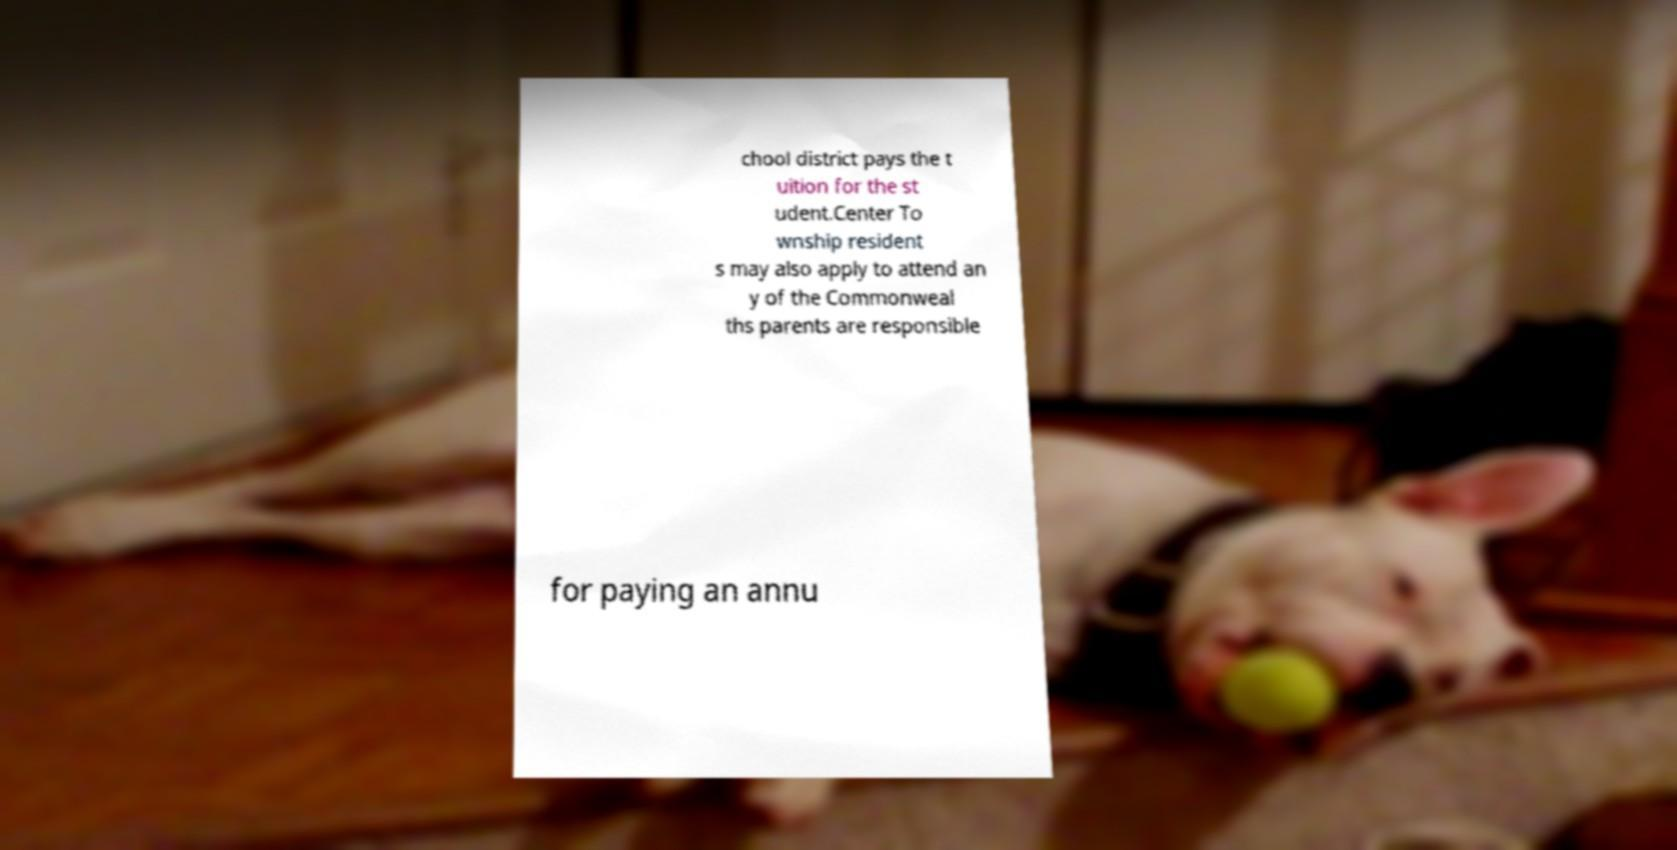Please read and relay the text visible in this image. What does it say? chool district pays the t uition for the st udent.Center To wnship resident s may also apply to attend an y of the Commonweal ths parents are responsible for paying an annu 